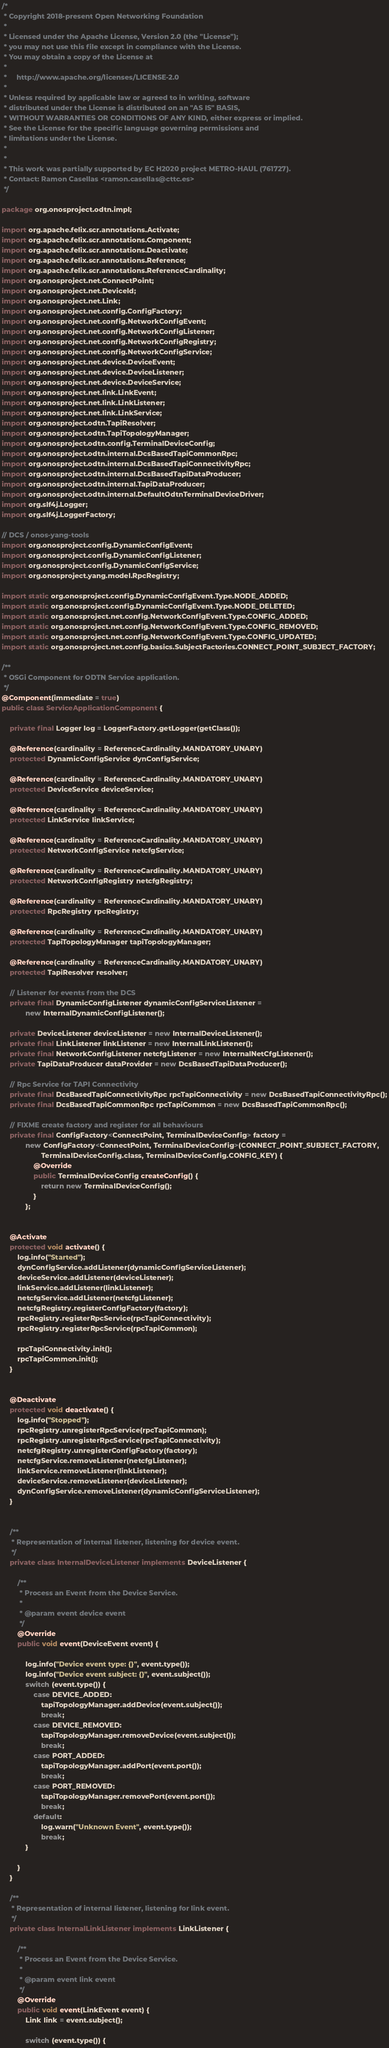<code> <loc_0><loc_0><loc_500><loc_500><_Java_>/*
 * Copyright 2018-present Open Networking Foundation
 *
 * Licensed under the Apache License, Version 2.0 (the "License");
 * you may not use this file except in compliance with the License.
 * You may obtain a copy of the License at
 *
 *     http://www.apache.org/licenses/LICENSE-2.0
 *
 * Unless required by applicable law or agreed to in writing, software
 * distributed under the License is distributed on an "AS IS" BASIS,
 * WITHOUT WARRANTIES OR CONDITIONS OF ANY KIND, either express or implied.
 * See the License for the specific language governing permissions and
 * limitations under the License.
 *
 *
 * This work was partially supported by EC H2020 project METRO-HAUL (761727).
 * Contact: Ramon Casellas <ramon.casellas@cttc.es>
 */

package org.onosproject.odtn.impl;

import org.apache.felix.scr.annotations.Activate;
import org.apache.felix.scr.annotations.Component;
import org.apache.felix.scr.annotations.Deactivate;
import org.apache.felix.scr.annotations.Reference;
import org.apache.felix.scr.annotations.ReferenceCardinality;
import org.onosproject.net.ConnectPoint;
import org.onosproject.net.DeviceId;
import org.onosproject.net.Link;
import org.onosproject.net.config.ConfigFactory;
import org.onosproject.net.config.NetworkConfigEvent;
import org.onosproject.net.config.NetworkConfigListener;
import org.onosproject.net.config.NetworkConfigRegistry;
import org.onosproject.net.config.NetworkConfigService;
import org.onosproject.net.device.DeviceEvent;
import org.onosproject.net.device.DeviceListener;
import org.onosproject.net.device.DeviceService;
import org.onosproject.net.link.LinkEvent;
import org.onosproject.net.link.LinkListener;
import org.onosproject.net.link.LinkService;
import org.onosproject.odtn.TapiResolver;
import org.onosproject.odtn.TapiTopologyManager;
import org.onosproject.odtn.config.TerminalDeviceConfig;
import org.onosproject.odtn.internal.DcsBasedTapiCommonRpc;
import org.onosproject.odtn.internal.DcsBasedTapiConnectivityRpc;
import org.onosproject.odtn.internal.DcsBasedTapiDataProducer;
import org.onosproject.odtn.internal.TapiDataProducer;
import org.onosproject.odtn.internal.DefaultOdtnTerminalDeviceDriver;
import org.slf4j.Logger;
import org.slf4j.LoggerFactory;

// DCS / onos-yang-tools
import org.onosproject.config.DynamicConfigEvent;
import org.onosproject.config.DynamicConfigListener;
import org.onosproject.config.DynamicConfigService;
import org.onosproject.yang.model.RpcRegistry;

import static org.onosproject.config.DynamicConfigEvent.Type.NODE_ADDED;
import static org.onosproject.config.DynamicConfigEvent.Type.NODE_DELETED;
import static org.onosproject.net.config.NetworkConfigEvent.Type.CONFIG_ADDED;
import static org.onosproject.net.config.NetworkConfigEvent.Type.CONFIG_REMOVED;
import static org.onosproject.net.config.NetworkConfigEvent.Type.CONFIG_UPDATED;
import static org.onosproject.net.config.basics.SubjectFactories.CONNECT_POINT_SUBJECT_FACTORY;

/**
 * OSGi Component for ODTN Service application.
 */
@Component(immediate = true)
public class ServiceApplicationComponent {

    private final Logger log = LoggerFactory.getLogger(getClass());

    @Reference(cardinality = ReferenceCardinality.MANDATORY_UNARY)
    protected DynamicConfigService dynConfigService;

    @Reference(cardinality = ReferenceCardinality.MANDATORY_UNARY)
    protected DeviceService deviceService;

    @Reference(cardinality = ReferenceCardinality.MANDATORY_UNARY)
    protected LinkService linkService;

    @Reference(cardinality = ReferenceCardinality.MANDATORY_UNARY)
    protected NetworkConfigService netcfgService;

    @Reference(cardinality = ReferenceCardinality.MANDATORY_UNARY)
    protected NetworkConfigRegistry netcfgRegistry;

    @Reference(cardinality = ReferenceCardinality.MANDATORY_UNARY)
    protected RpcRegistry rpcRegistry;

    @Reference(cardinality = ReferenceCardinality.MANDATORY_UNARY)
    protected TapiTopologyManager tapiTopologyManager;

    @Reference(cardinality = ReferenceCardinality.MANDATORY_UNARY)
    protected TapiResolver resolver;

    // Listener for events from the DCS
    private final DynamicConfigListener dynamicConfigServiceListener =
            new InternalDynamicConfigListener();

    private DeviceListener deviceListener = new InternalDeviceListener();
    private final LinkListener linkListener = new InternalLinkListener();
    private final NetworkConfigListener netcfgListener = new InternalNetCfgListener();
    private TapiDataProducer dataProvider = new DcsBasedTapiDataProducer();

    // Rpc Service for TAPI Connectivity
    private final DcsBasedTapiConnectivityRpc rpcTapiConnectivity = new DcsBasedTapiConnectivityRpc();
    private final DcsBasedTapiCommonRpc rpcTapiCommon = new DcsBasedTapiCommonRpc();

    // FIXME create factory and register for all behaviours
    private final ConfigFactory<ConnectPoint, TerminalDeviceConfig> factory =
            new ConfigFactory<ConnectPoint, TerminalDeviceConfig>(CONNECT_POINT_SUBJECT_FACTORY,
                    TerminalDeviceConfig.class, TerminalDeviceConfig.CONFIG_KEY) {
                @Override
                public TerminalDeviceConfig createConfig() {
                    return new TerminalDeviceConfig();
                }
            };


    @Activate
    protected void activate() {
        log.info("Started");
        dynConfigService.addListener(dynamicConfigServiceListener);
        deviceService.addListener(deviceListener);
        linkService.addListener(linkListener);
        netcfgService.addListener(netcfgListener);
        netcfgRegistry.registerConfigFactory(factory);
        rpcRegistry.registerRpcService(rpcTapiConnectivity);
        rpcRegistry.registerRpcService(rpcTapiCommon);

        rpcTapiConnectivity.init();
        rpcTapiCommon.init();
    }


    @Deactivate
    protected void deactivate() {
        log.info("Stopped");
        rpcRegistry.unregisterRpcService(rpcTapiCommon);
        rpcRegistry.unregisterRpcService(rpcTapiConnectivity);
        netcfgRegistry.unregisterConfigFactory(factory);
        netcfgService.removeListener(netcfgListener);
        linkService.removeListener(linkListener);
        deviceService.removeListener(deviceListener);
        dynConfigService.removeListener(dynamicConfigServiceListener);
    }


    /**
     * Representation of internal listener, listening for device event.
     */
    private class InternalDeviceListener implements DeviceListener {

        /**
         * Process an Event from the Device Service.
         *
         * @param event device event
         */
        @Override
        public void event(DeviceEvent event) {

            log.info("Device event type: {}", event.type());
            log.info("Device event subject: {}", event.subject());
            switch (event.type()) {
                case DEVICE_ADDED:
                    tapiTopologyManager.addDevice(event.subject());
                    break;
                case DEVICE_REMOVED:
                    tapiTopologyManager.removeDevice(event.subject());
                    break;
                case PORT_ADDED:
                    tapiTopologyManager.addPort(event.port());
                    break;
                case PORT_REMOVED:
                    tapiTopologyManager.removePort(event.port());
                    break;
                default:
                    log.warn("Unknown Event", event.type());
                    break;
            }

        }
    }

    /**
     * Representation of internal listener, listening for link event.
     */
    private class InternalLinkListener implements LinkListener {

        /**
         * Process an Event from the Device Service.
         *
         * @param event link event
         */
        @Override
        public void event(LinkEvent event) {
            Link link = event.subject();

            switch (event.type()) {</code> 